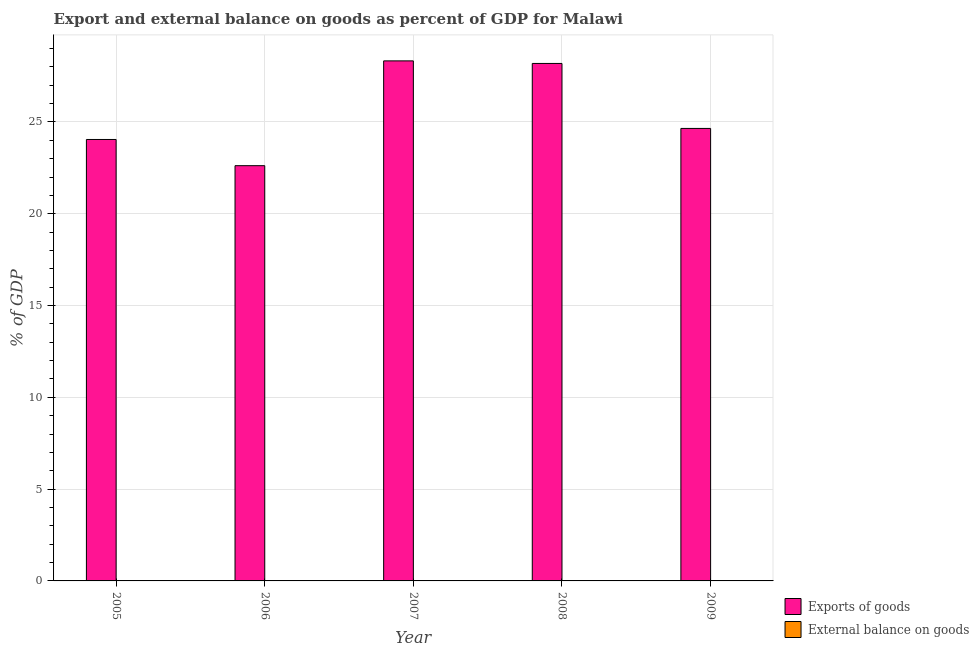Are the number of bars per tick equal to the number of legend labels?
Ensure brevity in your answer.  No. Are the number of bars on each tick of the X-axis equal?
Keep it short and to the point. Yes. How many bars are there on the 5th tick from the left?
Your answer should be compact. 1. What is the export of goods as percentage of gdp in 2006?
Offer a very short reply. 22.62. Across all years, what is the maximum export of goods as percentage of gdp?
Offer a very short reply. 28.33. Across all years, what is the minimum export of goods as percentage of gdp?
Offer a terse response. 22.62. In which year was the export of goods as percentage of gdp maximum?
Provide a succinct answer. 2007. What is the total export of goods as percentage of gdp in the graph?
Your response must be concise. 127.83. What is the difference between the export of goods as percentage of gdp in 2007 and that in 2009?
Ensure brevity in your answer.  3.68. What is the difference between the external balance on goods as percentage of gdp in 2008 and the export of goods as percentage of gdp in 2007?
Keep it short and to the point. 0. What is the average external balance on goods as percentage of gdp per year?
Your answer should be very brief. 0. In the year 2007, what is the difference between the export of goods as percentage of gdp and external balance on goods as percentage of gdp?
Offer a terse response. 0. In how many years, is the external balance on goods as percentage of gdp greater than 23 %?
Provide a short and direct response. 0. What is the ratio of the export of goods as percentage of gdp in 2008 to that in 2009?
Make the answer very short. 1.14. Is the export of goods as percentage of gdp in 2007 less than that in 2008?
Your answer should be very brief. No. What is the difference between the highest and the second highest export of goods as percentage of gdp?
Your answer should be compact. 0.14. What is the difference between the highest and the lowest export of goods as percentage of gdp?
Provide a short and direct response. 5.71. Is the sum of the export of goods as percentage of gdp in 2008 and 2009 greater than the maximum external balance on goods as percentage of gdp across all years?
Ensure brevity in your answer.  Yes. How many bars are there?
Keep it short and to the point. 5. How many years are there in the graph?
Your answer should be very brief. 5. What is the difference between two consecutive major ticks on the Y-axis?
Offer a terse response. 5. Are the values on the major ticks of Y-axis written in scientific E-notation?
Your answer should be very brief. No. What is the title of the graph?
Provide a short and direct response. Export and external balance on goods as percent of GDP for Malawi. What is the label or title of the Y-axis?
Give a very brief answer. % of GDP. What is the % of GDP of Exports of goods in 2005?
Your answer should be compact. 24.05. What is the % of GDP in External balance on goods in 2005?
Keep it short and to the point. 0. What is the % of GDP of Exports of goods in 2006?
Ensure brevity in your answer.  22.62. What is the % of GDP of Exports of goods in 2007?
Provide a short and direct response. 28.33. What is the % of GDP in Exports of goods in 2008?
Keep it short and to the point. 28.19. What is the % of GDP in External balance on goods in 2008?
Your answer should be very brief. 0. What is the % of GDP of Exports of goods in 2009?
Ensure brevity in your answer.  24.65. What is the % of GDP in External balance on goods in 2009?
Keep it short and to the point. 0. Across all years, what is the maximum % of GDP in Exports of goods?
Ensure brevity in your answer.  28.33. Across all years, what is the minimum % of GDP in Exports of goods?
Offer a very short reply. 22.62. What is the total % of GDP in Exports of goods in the graph?
Make the answer very short. 127.83. What is the difference between the % of GDP in Exports of goods in 2005 and that in 2006?
Keep it short and to the point. 1.43. What is the difference between the % of GDP of Exports of goods in 2005 and that in 2007?
Keep it short and to the point. -4.28. What is the difference between the % of GDP in Exports of goods in 2005 and that in 2008?
Give a very brief answer. -4.14. What is the difference between the % of GDP of Exports of goods in 2005 and that in 2009?
Provide a succinct answer. -0.6. What is the difference between the % of GDP in Exports of goods in 2006 and that in 2007?
Ensure brevity in your answer.  -5.71. What is the difference between the % of GDP in Exports of goods in 2006 and that in 2008?
Provide a short and direct response. -5.57. What is the difference between the % of GDP in Exports of goods in 2006 and that in 2009?
Provide a succinct answer. -2.03. What is the difference between the % of GDP of Exports of goods in 2007 and that in 2008?
Give a very brief answer. 0.14. What is the difference between the % of GDP in Exports of goods in 2007 and that in 2009?
Ensure brevity in your answer.  3.68. What is the difference between the % of GDP of Exports of goods in 2008 and that in 2009?
Provide a short and direct response. 3.54. What is the average % of GDP in Exports of goods per year?
Your response must be concise. 25.57. What is the ratio of the % of GDP in Exports of goods in 2005 to that in 2006?
Give a very brief answer. 1.06. What is the ratio of the % of GDP in Exports of goods in 2005 to that in 2007?
Your answer should be compact. 0.85. What is the ratio of the % of GDP in Exports of goods in 2005 to that in 2008?
Make the answer very short. 0.85. What is the ratio of the % of GDP in Exports of goods in 2005 to that in 2009?
Ensure brevity in your answer.  0.98. What is the ratio of the % of GDP of Exports of goods in 2006 to that in 2007?
Ensure brevity in your answer.  0.8. What is the ratio of the % of GDP of Exports of goods in 2006 to that in 2008?
Keep it short and to the point. 0.8. What is the ratio of the % of GDP in Exports of goods in 2006 to that in 2009?
Offer a very short reply. 0.92. What is the ratio of the % of GDP of Exports of goods in 2007 to that in 2008?
Provide a short and direct response. 1. What is the ratio of the % of GDP of Exports of goods in 2007 to that in 2009?
Ensure brevity in your answer.  1.15. What is the ratio of the % of GDP of Exports of goods in 2008 to that in 2009?
Ensure brevity in your answer.  1.14. What is the difference between the highest and the second highest % of GDP of Exports of goods?
Give a very brief answer. 0.14. What is the difference between the highest and the lowest % of GDP in Exports of goods?
Your answer should be very brief. 5.71. 